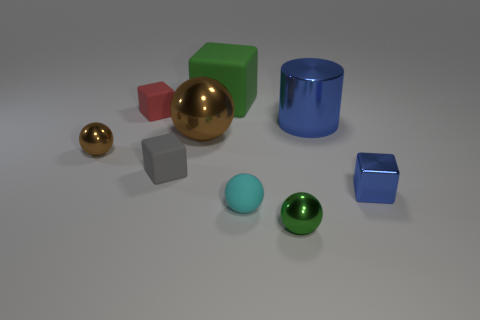Is there any other thing that is the same shape as the big blue metallic object?
Ensure brevity in your answer.  No. How many large objects are either brown balls or purple rubber cubes?
Give a very brief answer. 1. Are there the same number of things behind the small gray object and tiny cyan spheres that are on the left side of the matte sphere?
Your answer should be very brief. No. What number of other blue metallic blocks are the same size as the metal cube?
Make the answer very short. 0. How many purple objects are either small balls or matte blocks?
Make the answer very short. 0. Are there the same number of cylinders that are in front of the cyan matte object and brown metallic balls?
Your response must be concise. No. How big is the blue metal thing that is to the left of the blue cube?
Offer a terse response. Large. How many tiny green shiny things have the same shape as the big brown metallic object?
Offer a very short reply. 1. There is a thing that is in front of the large blue thing and behind the tiny brown object; what material is it?
Your response must be concise. Metal. Are the small brown sphere and the big green block made of the same material?
Give a very brief answer. No. 